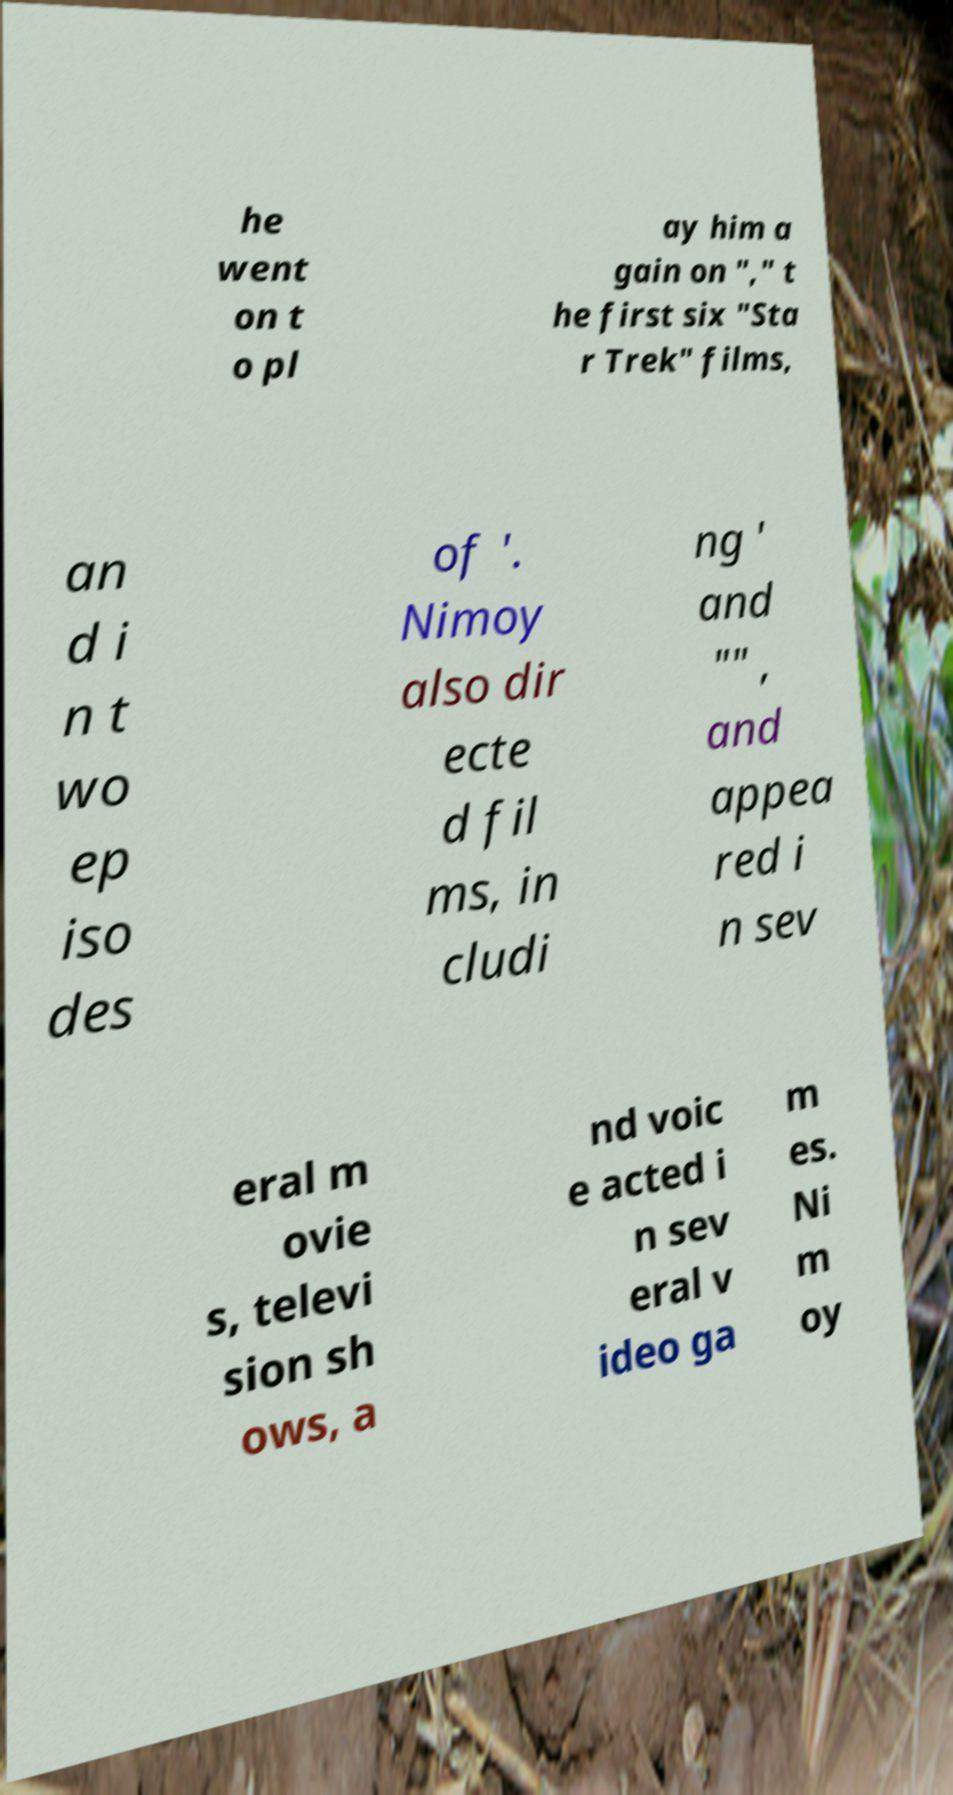What messages or text are displayed in this image? I need them in a readable, typed format. he went on t o pl ay him a gain on "," t he first six "Sta r Trek" films, an d i n t wo ep iso des of '. Nimoy also dir ecte d fil ms, in cludi ng ' and "" , and appea red i n sev eral m ovie s, televi sion sh ows, a nd voic e acted i n sev eral v ideo ga m es. Ni m oy 